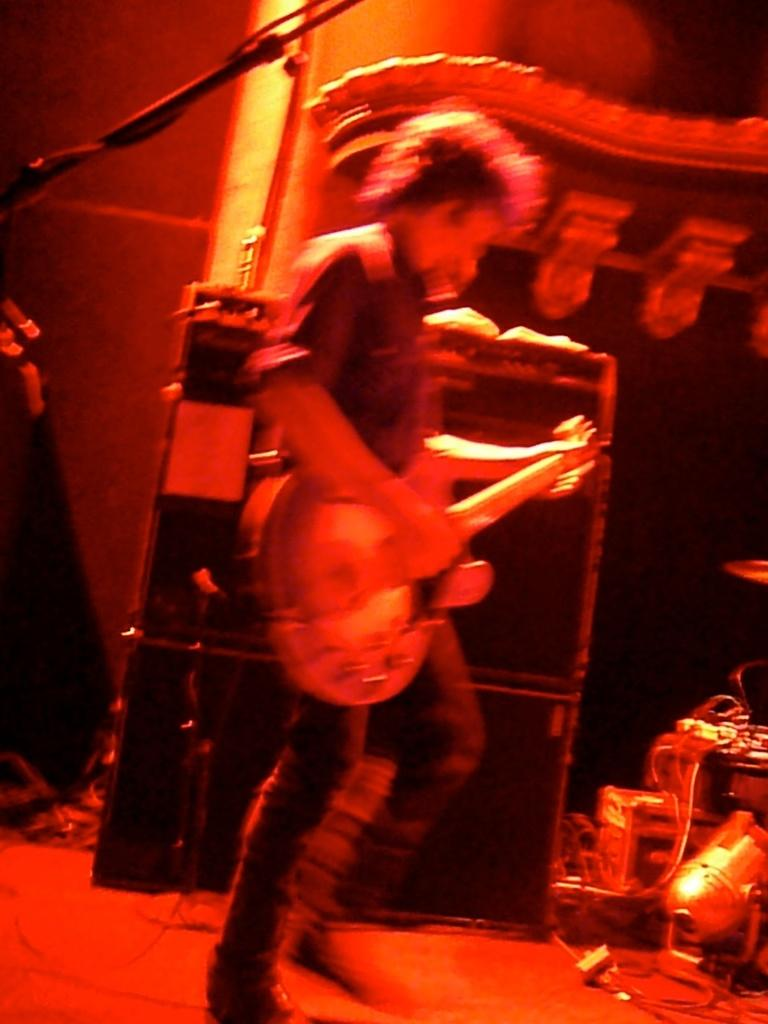What is the man in the image doing? The man is playing a guitar in the image. What object is in front of the man? There is a microphone in front of the man. What can be seen in the background of the image? There are musical instruments in the background of the image. What month is the man wearing on his shirt in the image? There is no shirt mentioned in the image, and the man is not wearing any month on his clothing. 